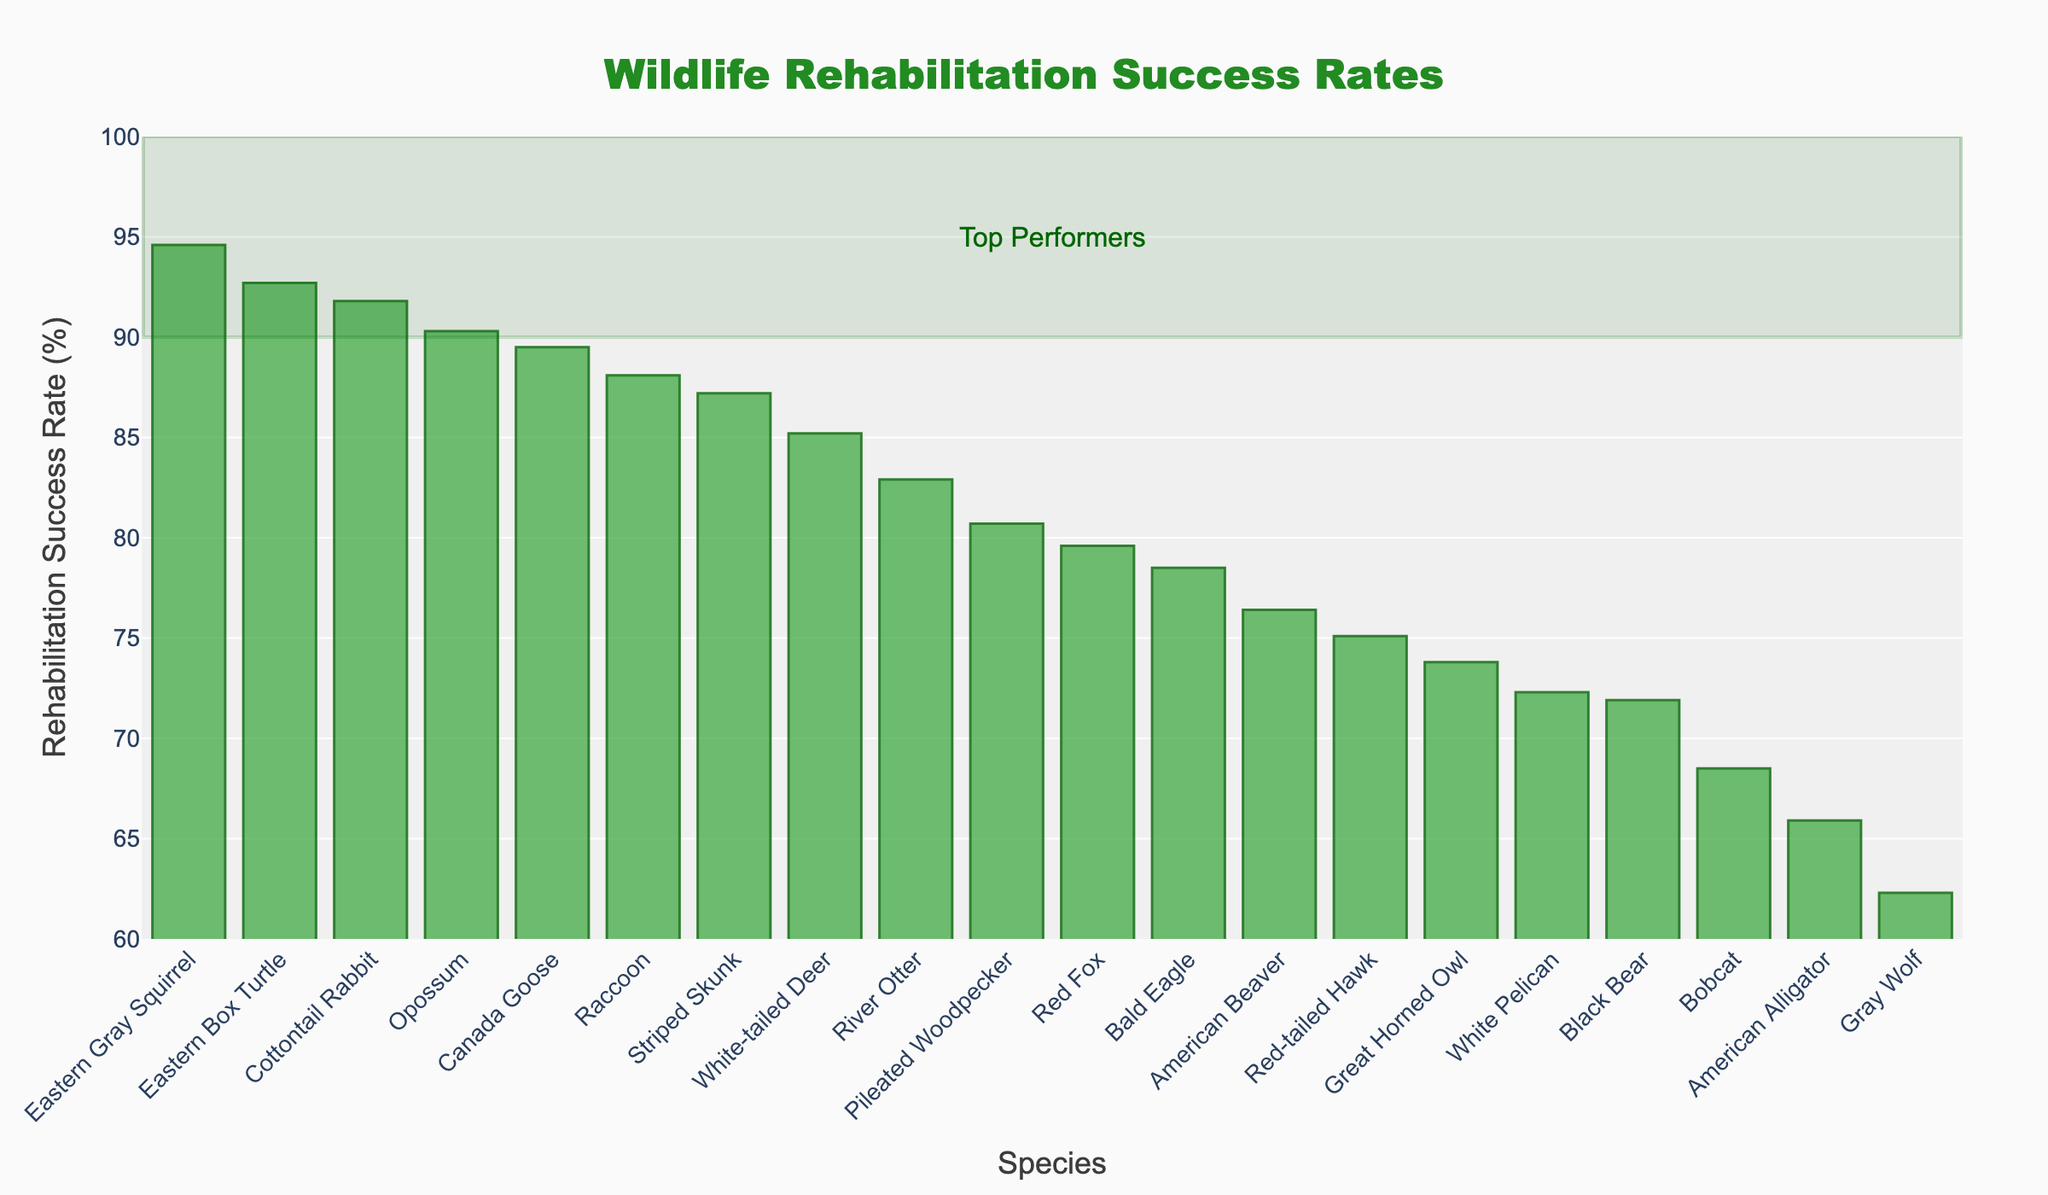What's the species with the highest rehabilitation success rate? Look for the bar with the greatest height. The Eastern Gray Squirrel has the highest success rate at 94.6%.
Answer: Eastern Gray Squirrel How many species have a success rate above 90%? Count the number of bars that extend above the 90% mark. There are six species: Eastern Gray Squirrel (94.6%), Eastern Box Turtle (92.7%), Cottontail Rabbit (91.8%), Opossum (90.3%), Canada Goose (89.5%), and Raccoon (88.1%).
Answer: 6 Which species shows the lowest rehabilitation success rate? Find the shortest bar on the chart. The American Alligator has the lowest success rate at 65.9%.
Answer: American Alligator What is the approximate average rehabilitation success rate of the Bald Eagle, Great Horned Owl, and Red-tailed Hawk combined? Add the success rates of the Bald Eagle (78.5%), Great Horned Owl (73.8%), and Red-tailed Hawk (75.1%) together and divide by 3. (78.5 + 73.8 + 75.1) / 3 = 75.8%
Answer: 75.8% How does the success rate of the White-tailed Deer compare to the River Otter? Identify the heights of the respective bars and compare. The White-tailed Deer (85.2%) has a lower success rate compared to the River Otter (82.9%).
Answer: Higher Which species falls closest to the median rehabilitation success rate? Organize the success rates in ascending order and find the middle value. The median species falls between Red Fox (79.6%) and Pileated Woodpecker (80.7%).
Answer: Pileated Woodpecker What is the range of rehabilitation success rates observed in the chart? Determine the difference between the highest and lowest success rates. The highest rate is 94.6% (Eastern Gray Squirrel) and the lowest is 65.9% (American Alligator). 94.6% - 65.9% = 28.7%
Answer: 28.7% Which species has a success rate just above 70%? Identify the bar slightly above the 70% mark. The Black Bear has a success rate of 71.9%.
Answer: Black Bear What can be inferred about the success rates of bird species compared to mammal species? Notice the bars for various bird and mammal species. Birds generally have slightly lower success rates compared to mammals. For example, Red-tailed Hawk (75.1%), Great Horned Owl (73.8%) vs. Raccoon (88.1%), Bobcat (68.5%).
Answer: Birds generally lower Are there any species that fall into the "Top Performers" rectangle, having a success rate of 90% or higher? Check if any bars fall into the highlighted rectangle area for top performers (90% and above). Those species are Eastern Gray Squirrel, Eastern Box Turtle, Cottontail Rabbit, Opossum, Canada Goose, and Raccoon.
Answer: Yes 